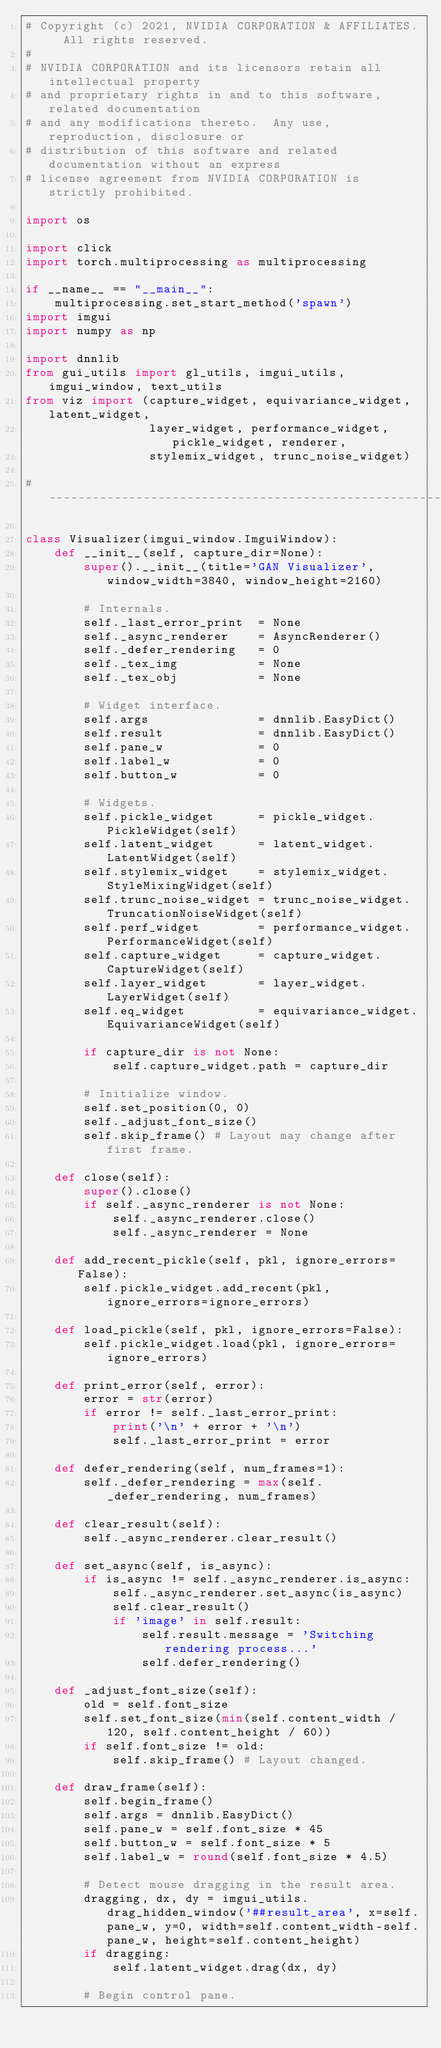<code> <loc_0><loc_0><loc_500><loc_500><_Python_># Copyright (c) 2021, NVIDIA CORPORATION & AFFILIATES.  All rights reserved.
#
# NVIDIA CORPORATION and its licensors retain all intellectual property
# and proprietary rights in and to this software, related documentation
# and any modifications thereto.  Any use, reproduction, disclosure or
# distribution of this software and related documentation without an express
# license agreement from NVIDIA CORPORATION is strictly prohibited.

import os

import click
import torch.multiprocessing as multiprocessing

if __name__ == "__main__":
    multiprocessing.set_start_method('spawn')
import imgui
import numpy as np

import dnnlib
from gui_utils import gl_utils, imgui_utils, imgui_window, text_utils
from viz import (capture_widget, equivariance_widget, latent_widget,
                 layer_widget, performance_widget, pickle_widget, renderer,
                 stylemix_widget, trunc_noise_widget)

#----------------------------------------------------------------------------

class Visualizer(imgui_window.ImguiWindow):
    def __init__(self, capture_dir=None):
        super().__init__(title='GAN Visualizer', window_width=3840, window_height=2160)

        # Internals.
        self._last_error_print  = None
        self._async_renderer    = AsyncRenderer()
        self._defer_rendering   = 0
        self._tex_img           = None
        self._tex_obj           = None

        # Widget interface.
        self.args               = dnnlib.EasyDict()
        self.result             = dnnlib.EasyDict()
        self.pane_w             = 0
        self.label_w            = 0
        self.button_w           = 0

        # Widgets.
        self.pickle_widget      = pickle_widget.PickleWidget(self)
        self.latent_widget      = latent_widget.LatentWidget(self)
        self.stylemix_widget    = stylemix_widget.StyleMixingWidget(self)
        self.trunc_noise_widget = trunc_noise_widget.TruncationNoiseWidget(self)
        self.perf_widget        = performance_widget.PerformanceWidget(self)
        self.capture_widget     = capture_widget.CaptureWidget(self)
        self.layer_widget       = layer_widget.LayerWidget(self)
        self.eq_widget          = equivariance_widget.EquivarianceWidget(self)

        if capture_dir is not None:
            self.capture_widget.path = capture_dir

        # Initialize window.
        self.set_position(0, 0)
        self._adjust_font_size()
        self.skip_frame() # Layout may change after first frame.

    def close(self):
        super().close()
        if self._async_renderer is not None:
            self._async_renderer.close()
            self._async_renderer = None

    def add_recent_pickle(self, pkl, ignore_errors=False):
        self.pickle_widget.add_recent(pkl, ignore_errors=ignore_errors)

    def load_pickle(self, pkl, ignore_errors=False):
        self.pickle_widget.load(pkl, ignore_errors=ignore_errors)

    def print_error(self, error):
        error = str(error)
        if error != self._last_error_print:
            print('\n' + error + '\n')
            self._last_error_print = error

    def defer_rendering(self, num_frames=1):
        self._defer_rendering = max(self._defer_rendering, num_frames)

    def clear_result(self):
        self._async_renderer.clear_result()

    def set_async(self, is_async):
        if is_async != self._async_renderer.is_async:
            self._async_renderer.set_async(is_async)
            self.clear_result()
            if 'image' in self.result:
                self.result.message = 'Switching rendering process...'
                self.defer_rendering()

    def _adjust_font_size(self):
        old = self.font_size
        self.set_font_size(min(self.content_width / 120, self.content_height / 60))
        if self.font_size != old:
            self.skip_frame() # Layout changed.

    def draw_frame(self):
        self.begin_frame()
        self.args = dnnlib.EasyDict()
        self.pane_w = self.font_size * 45
        self.button_w = self.font_size * 5
        self.label_w = round(self.font_size * 4.5)

        # Detect mouse dragging in the result area.
        dragging, dx, dy = imgui_utils.drag_hidden_window('##result_area', x=self.pane_w, y=0, width=self.content_width-self.pane_w, height=self.content_height)
        if dragging:
            self.latent_widget.drag(dx, dy)

        # Begin control pane.</code> 